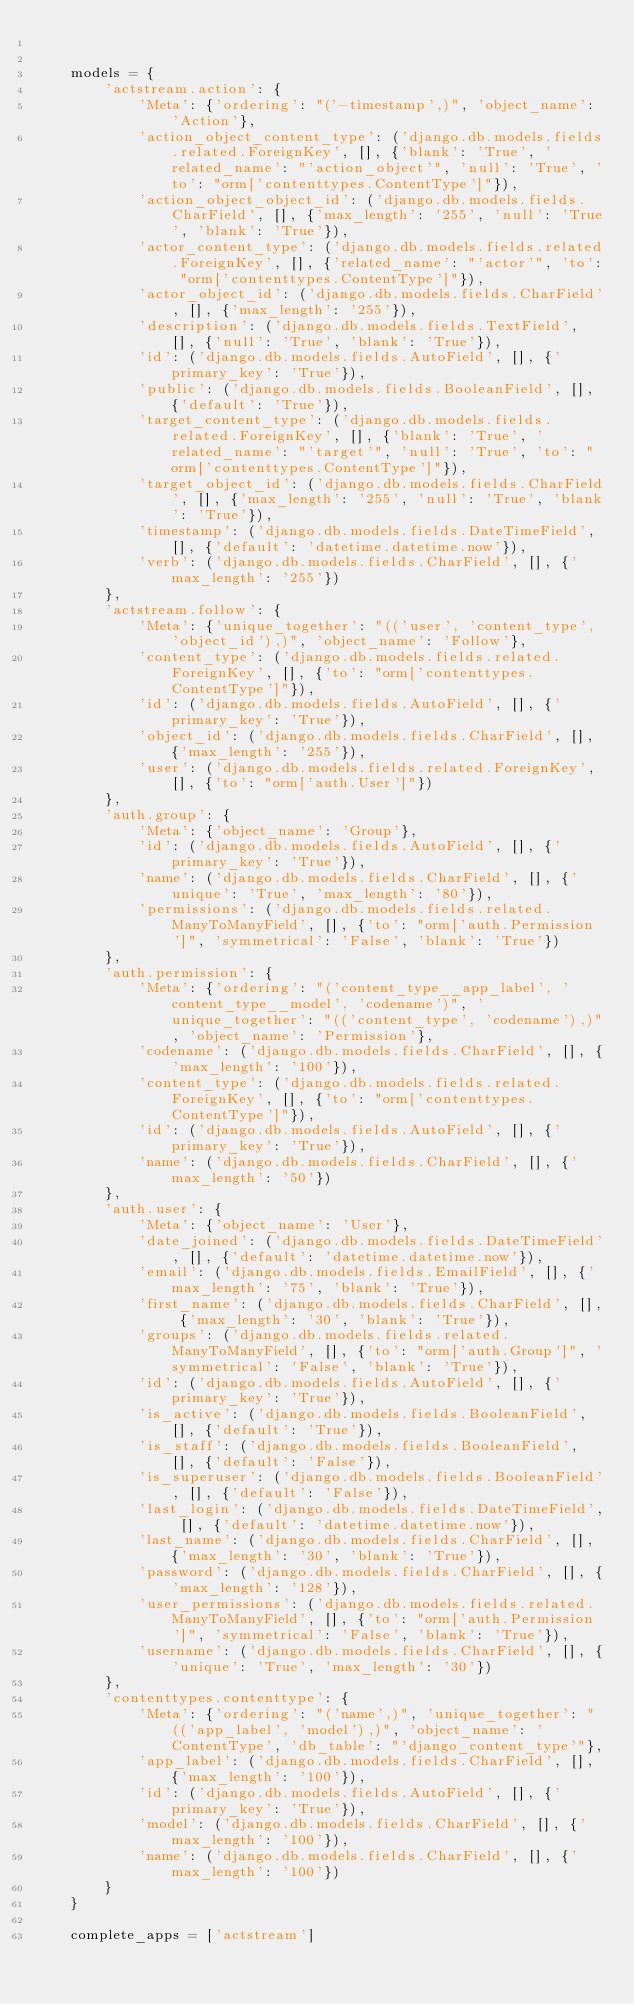Convert code to text. <code><loc_0><loc_0><loc_500><loc_500><_Python_>

    models = {
        'actstream.action': {
            'Meta': {'ordering': "('-timestamp',)", 'object_name': 'Action'},
            'action_object_content_type': ('django.db.models.fields.related.ForeignKey', [], {'blank': 'True', 'related_name': "'action_object'", 'null': 'True', 'to': "orm['contenttypes.ContentType']"}),
            'action_object_object_id': ('django.db.models.fields.CharField', [], {'max_length': '255', 'null': 'True', 'blank': 'True'}),
            'actor_content_type': ('django.db.models.fields.related.ForeignKey', [], {'related_name': "'actor'", 'to': "orm['contenttypes.ContentType']"}),
            'actor_object_id': ('django.db.models.fields.CharField', [], {'max_length': '255'}),
            'description': ('django.db.models.fields.TextField', [], {'null': 'True', 'blank': 'True'}),
            'id': ('django.db.models.fields.AutoField', [], {'primary_key': 'True'}),
            'public': ('django.db.models.fields.BooleanField', [], {'default': 'True'}),
            'target_content_type': ('django.db.models.fields.related.ForeignKey', [], {'blank': 'True', 'related_name': "'target'", 'null': 'True', 'to': "orm['contenttypes.ContentType']"}),
            'target_object_id': ('django.db.models.fields.CharField', [], {'max_length': '255', 'null': 'True', 'blank': 'True'}),
            'timestamp': ('django.db.models.fields.DateTimeField', [], {'default': 'datetime.datetime.now'}),
            'verb': ('django.db.models.fields.CharField', [], {'max_length': '255'})
        },
        'actstream.follow': {
            'Meta': {'unique_together': "(('user', 'content_type', 'object_id'),)", 'object_name': 'Follow'},
            'content_type': ('django.db.models.fields.related.ForeignKey', [], {'to': "orm['contenttypes.ContentType']"}),
            'id': ('django.db.models.fields.AutoField', [], {'primary_key': 'True'}),
            'object_id': ('django.db.models.fields.CharField', [], {'max_length': '255'}),
            'user': ('django.db.models.fields.related.ForeignKey', [], {'to': "orm['auth.User']"})
        },
        'auth.group': {
            'Meta': {'object_name': 'Group'},
            'id': ('django.db.models.fields.AutoField', [], {'primary_key': 'True'}),
            'name': ('django.db.models.fields.CharField', [], {'unique': 'True', 'max_length': '80'}),
            'permissions': ('django.db.models.fields.related.ManyToManyField', [], {'to': "orm['auth.Permission']", 'symmetrical': 'False', 'blank': 'True'})
        },
        'auth.permission': {
            'Meta': {'ordering': "('content_type__app_label', 'content_type__model', 'codename')", 'unique_together': "(('content_type', 'codename'),)", 'object_name': 'Permission'},
            'codename': ('django.db.models.fields.CharField', [], {'max_length': '100'}),
            'content_type': ('django.db.models.fields.related.ForeignKey', [], {'to': "orm['contenttypes.ContentType']"}),
            'id': ('django.db.models.fields.AutoField', [], {'primary_key': 'True'}),
            'name': ('django.db.models.fields.CharField', [], {'max_length': '50'})
        },
        'auth.user': {
            'Meta': {'object_name': 'User'},
            'date_joined': ('django.db.models.fields.DateTimeField', [], {'default': 'datetime.datetime.now'}),
            'email': ('django.db.models.fields.EmailField', [], {'max_length': '75', 'blank': 'True'}),
            'first_name': ('django.db.models.fields.CharField', [], {'max_length': '30', 'blank': 'True'}),
            'groups': ('django.db.models.fields.related.ManyToManyField', [], {'to': "orm['auth.Group']", 'symmetrical': 'False', 'blank': 'True'}),
            'id': ('django.db.models.fields.AutoField', [], {'primary_key': 'True'}),
            'is_active': ('django.db.models.fields.BooleanField', [], {'default': 'True'}),
            'is_staff': ('django.db.models.fields.BooleanField', [], {'default': 'False'}),
            'is_superuser': ('django.db.models.fields.BooleanField', [], {'default': 'False'}),
            'last_login': ('django.db.models.fields.DateTimeField', [], {'default': 'datetime.datetime.now'}),
            'last_name': ('django.db.models.fields.CharField', [], {'max_length': '30', 'blank': 'True'}),
            'password': ('django.db.models.fields.CharField', [], {'max_length': '128'}),
            'user_permissions': ('django.db.models.fields.related.ManyToManyField', [], {'to': "orm['auth.Permission']", 'symmetrical': 'False', 'blank': 'True'}),
            'username': ('django.db.models.fields.CharField', [], {'unique': 'True', 'max_length': '30'})
        },
        'contenttypes.contenttype': {
            'Meta': {'ordering': "('name',)", 'unique_together': "(('app_label', 'model'),)", 'object_name': 'ContentType', 'db_table': "'django_content_type'"},
            'app_label': ('django.db.models.fields.CharField', [], {'max_length': '100'}),
            'id': ('django.db.models.fields.AutoField', [], {'primary_key': 'True'}),
            'model': ('django.db.models.fields.CharField', [], {'max_length': '100'}),
            'name': ('django.db.models.fields.CharField', [], {'max_length': '100'})
        }
    }

    complete_apps = ['actstream']
</code> 